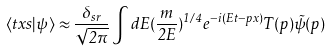Convert formula to latex. <formula><loc_0><loc_0><loc_500><loc_500>\langle t x s | \psi \rangle \approx \frac { \delta _ { s r } } { \sqrt { 2 \pi } } \int d E ( \frac { m } { 2 E } ) ^ { 1 / 4 } e ^ { - i ( E t - p x ) } T ( p ) \tilde { \psi } ( p )</formula> 